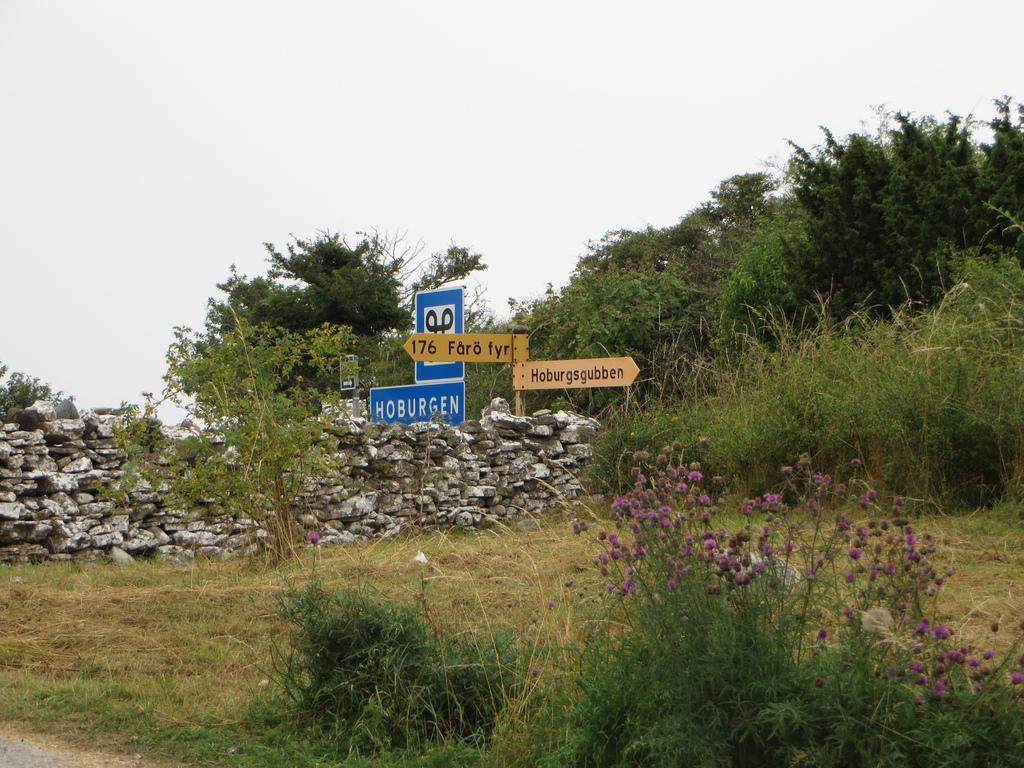In one or two sentences, can you explain what this image depicts? In this picture there are sign boards and pebbles in the center of the image and there is greenery in the image. 